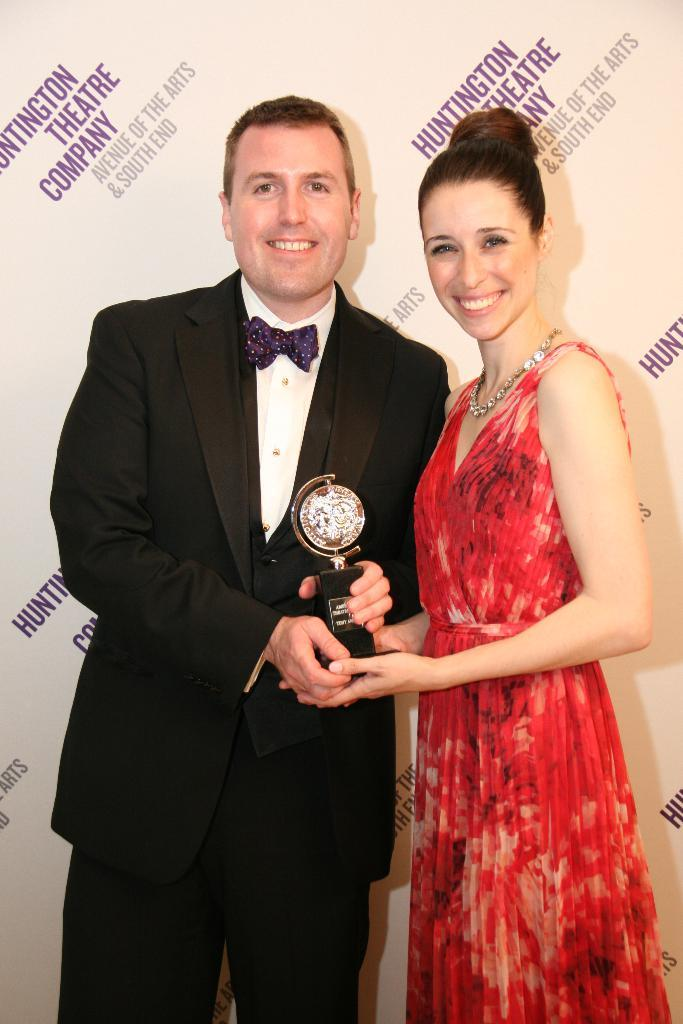<image>
Give a short and clear explanation of the subsequent image. Man and woman posing for a picture in front of a background that says "Huntington Theatre Company". 